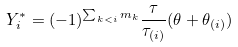<formula> <loc_0><loc_0><loc_500><loc_500>Y _ { i } ^ { * } = ( - 1 ) ^ { \sum _ { k < i } m _ { k } } \frac { \tau } { \tau _ { ( i ) } } ( \theta + \theta _ { ( i ) } )</formula> 